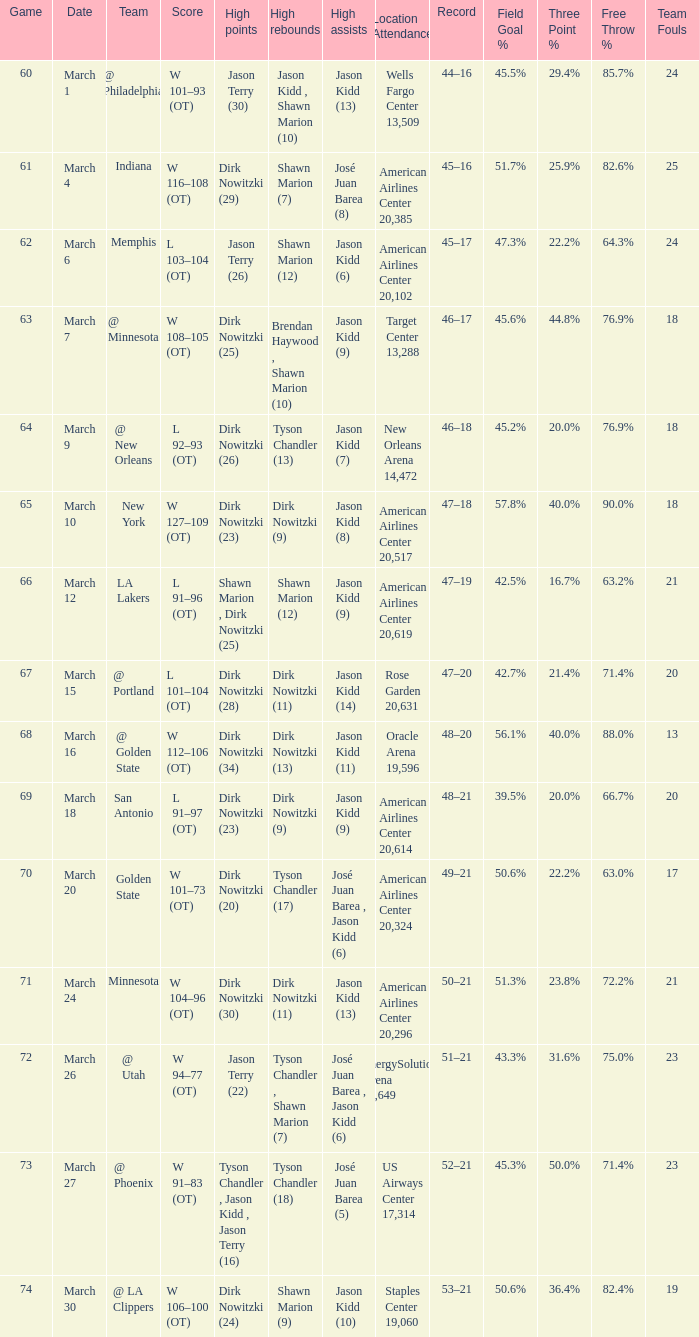Name the high assists for  l 103–104 (ot) Jason Kidd (6). 